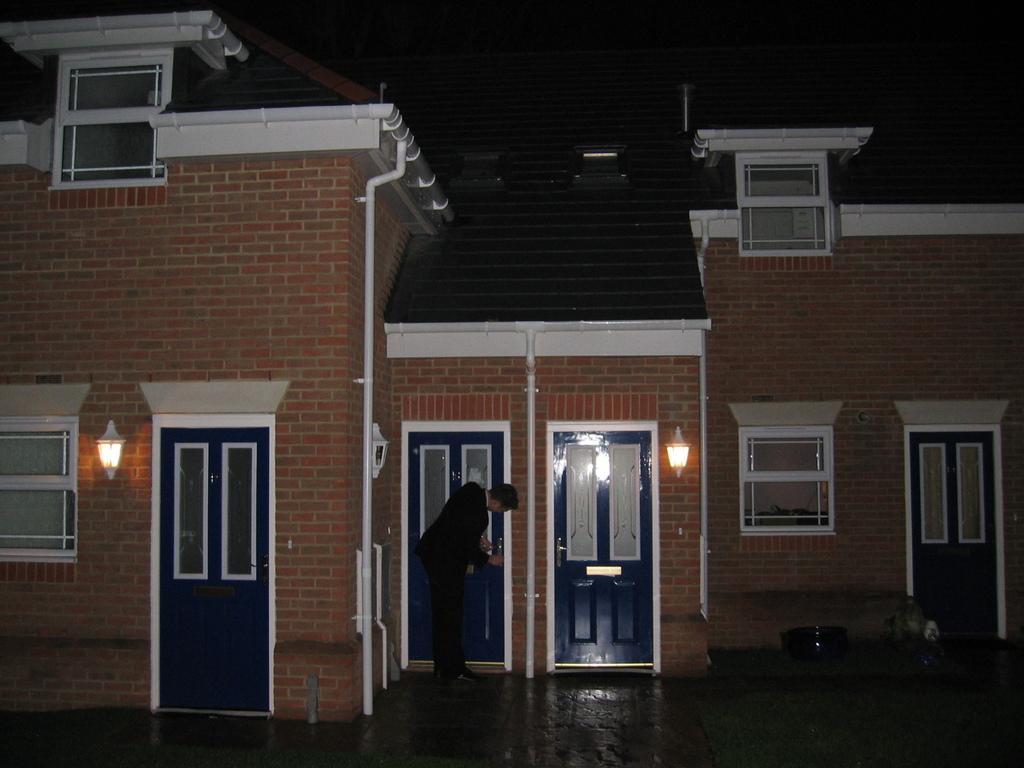Can you describe this image briefly? In this image in the center there is one house, and in the center there is one person it seems that he is locking the door and also there are some lights windows and doors. At the bottom there is walkway, and on the left side of the image there are some objects. 